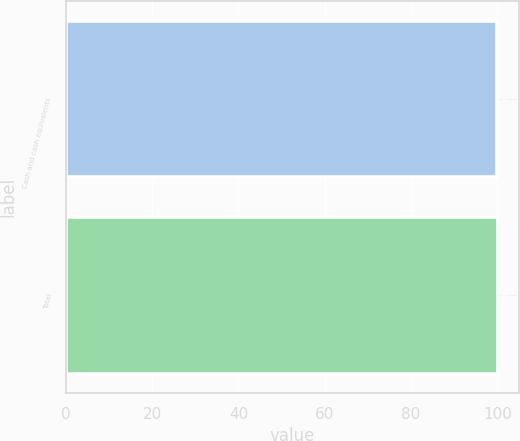<chart> <loc_0><loc_0><loc_500><loc_500><bar_chart><fcel>Cash and cash equivalents<fcel>Total<nl><fcel>100<fcel>100.1<nl></chart> 